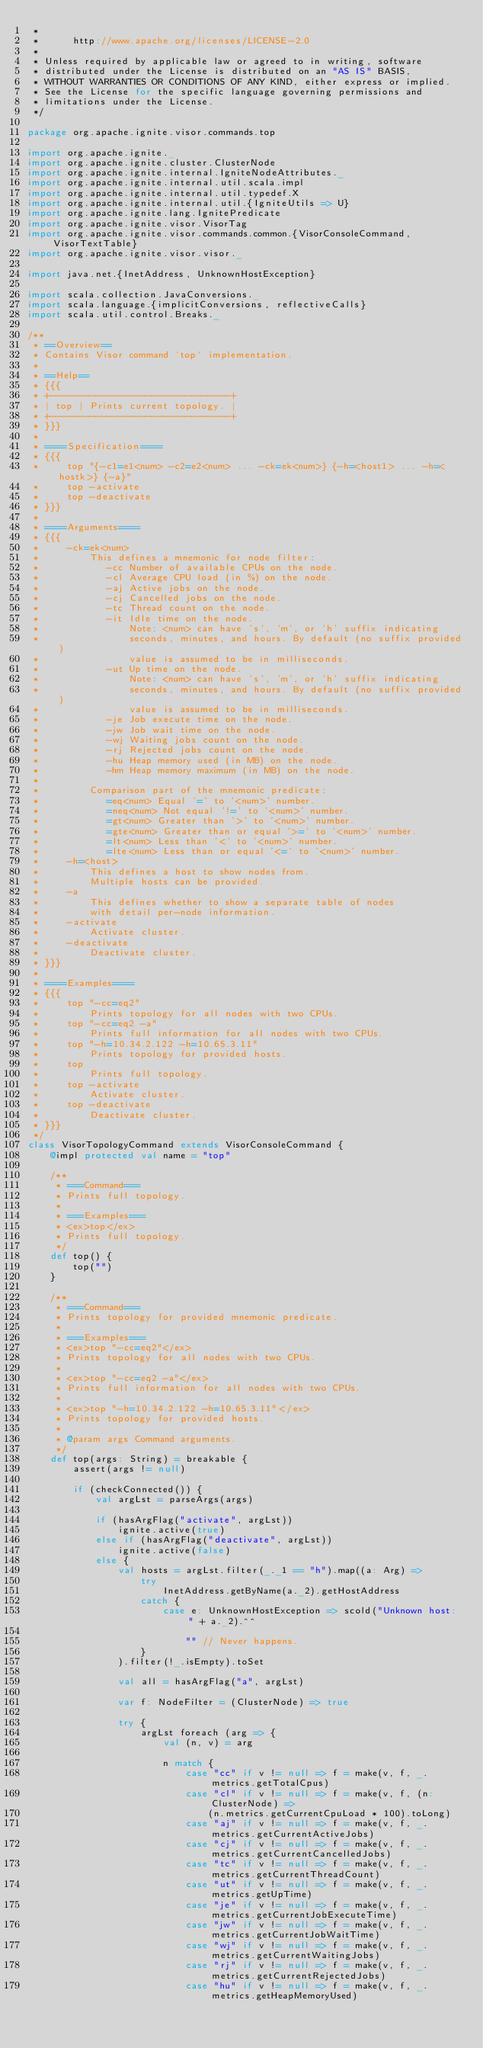Convert code to text. <code><loc_0><loc_0><loc_500><loc_500><_Scala_> *
 *      http://www.apache.org/licenses/LICENSE-2.0
 *
 * Unless required by applicable law or agreed to in writing, software
 * distributed under the License is distributed on an "AS IS" BASIS,
 * WITHOUT WARRANTIES OR CONDITIONS OF ANY KIND, either express or implied.
 * See the License for the specific language governing permissions and
 * limitations under the License.
 */

package org.apache.ignite.visor.commands.top

import org.apache.ignite._
import org.apache.ignite.cluster.ClusterNode
import org.apache.ignite.internal.IgniteNodeAttributes._
import org.apache.ignite.internal.util.scala.impl
import org.apache.ignite.internal.util.typedef.X
import org.apache.ignite.internal.util.{IgniteUtils => U}
import org.apache.ignite.lang.IgnitePredicate
import org.apache.ignite.visor.VisorTag
import org.apache.ignite.visor.commands.common.{VisorConsoleCommand, VisorTextTable}
import org.apache.ignite.visor.visor._

import java.net.{InetAddress, UnknownHostException}

import scala.collection.JavaConversions._
import scala.language.{implicitConversions, reflectiveCalls}
import scala.util.control.Breaks._

/**
 * ==Overview==
 * Contains Visor command `top` implementation.
 *
 * ==Help==
 * {{{
 * +--------------------------------+
 * | top | Prints current topology. |
 * +--------------------------------+
 * }}}
 *
 * ====Specification====
 * {{{
 *     top "{-c1=e1<num> -c2=e2<num> ... -ck=ek<num>} {-h=<host1> ... -h=<hostk>} {-a}"
 *     top -activate
 *     top -deactivate
 * }}}
 *
 * ====Arguments====
 * {{{
 *     -ck=ek<num>
 *         This defines a mnemonic for node filter:
 *            -cc Number of available CPUs on the node.
 *            -cl Average CPU load (in %) on the node.
 *            -aj Active jobs on the node.
 *            -cj Cancelled jobs on the node.
 *            -tc Thread count on the node.
 *            -it Idle time on the node.
 *                Note: <num> can have 's', 'm', or 'h' suffix indicating
 *                seconds, minutes, and hours. By default (no suffix provided)
 *                value is assumed to be in milliseconds.
 *            -ut Up time on the node.
 *                Note: <num> can have 's', 'm', or 'h' suffix indicating
 *                seconds, minutes, and hours. By default (no suffix provided)
 *                value is assumed to be in milliseconds.
 *            -je Job execute time on the node.
 *            -jw Job wait time on the node.
 *            -wj Waiting jobs count on the node.
 *            -rj Rejected jobs count on the node.
 *            -hu Heap memory used (in MB) on the node.
 *            -hm Heap memory maximum (in MB) on the node.
 *
 *         Comparison part of the mnemonic predicate:
 *            =eq<num> Equal '=' to '<num>' number.
 *            =neq<num> Not equal '!=' to '<num>' number.
 *            =gt<num> Greater than '>' to '<num>' number.
 *            =gte<num> Greater than or equal '>=' to '<num>' number.
 *            =lt<num> Less than '<' to '<num>' number.
 *            =lte<num> Less than or equal '<=' to '<num>' number.
 *     -h=<host>
 *         This defines a host to show nodes from.
 *         Multiple hosts can be provided.
 *     -a
 *         This defines whether to show a separate table of nodes
 *         with detail per-node information.
 *     -activate
 *         Activate cluster.
 *     -deactivate
 *         Deactivate cluster.
 * }}}
 *
 * ====Examples====
 * {{{
 *     top "-cc=eq2"
 *         Prints topology for all nodes with two CPUs.
 *     top "-cc=eq2 -a"
 *         Prints full information for all nodes with two CPUs.
 *     top "-h=10.34.2.122 -h=10.65.3.11"
 *         Prints topology for provided hosts.
 *     top
 *         Prints full topology.
 *     top -activate
 *         Activate cluster.
 *     top -deactivate
 *         Deactivate cluster.
 * }}}
 */
class VisorTopologyCommand extends VisorConsoleCommand {
    @impl protected val name = "top"

    /**
     * ===Command===
     * Prints full topology.
     *
     * ===Examples===
     * <ex>top</ex>
     * Prints full topology.
     */
    def top() {
        top("")
    }

    /**
     * ===Command===
     * Prints topology for provided mnemonic predicate.
     *
     * ===Examples===
     * <ex>top "-cc=eq2"</ex>
     * Prints topology for all nodes with two CPUs.
     *
     * <ex>top "-cc=eq2 -a"</ex>
     * Prints full information for all nodes with two CPUs.
     *
     * <ex>top "-h=10.34.2.122 -h=10.65.3.11"</ex>
     * Prints topology for provided hosts.
     *
     * @param args Command arguments.
     */
    def top(args: String) = breakable {
        assert(args != null)

        if (checkConnected()) {
            val argLst = parseArgs(args)

            if (hasArgFlag("activate", argLst))
                ignite.active(true)
            else if (hasArgFlag("deactivate", argLst))
                ignite.active(false)
            else {
                val hosts = argLst.filter(_._1 == "h").map((a: Arg) =>
                    try
                        InetAddress.getByName(a._2).getHostAddress
                    catch {
                        case e: UnknownHostException => scold("Unknown host: " + a._2).^^

                            "" // Never happens.
                    }
                ).filter(!_.isEmpty).toSet

                val all = hasArgFlag("a", argLst)

                var f: NodeFilter = (ClusterNode) => true

                try {
                    argLst foreach (arg => {
                        val (n, v) = arg

                        n match {
                            case "cc" if v != null => f = make(v, f, _.metrics.getTotalCpus)
                            case "cl" if v != null => f = make(v, f, (n: ClusterNode) =>
                                (n.metrics.getCurrentCpuLoad * 100).toLong)
                            case "aj" if v != null => f = make(v, f, _.metrics.getCurrentActiveJobs)
                            case "cj" if v != null => f = make(v, f, _.metrics.getCurrentCancelledJobs)
                            case "tc" if v != null => f = make(v, f, _.metrics.getCurrentThreadCount)
                            case "ut" if v != null => f = make(v, f, _.metrics.getUpTime)
                            case "je" if v != null => f = make(v, f, _.metrics.getCurrentJobExecuteTime)
                            case "jw" if v != null => f = make(v, f, _.metrics.getCurrentJobWaitTime)
                            case "wj" if v != null => f = make(v, f, _.metrics.getCurrentWaitingJobs)
                            case "rj" if v != null => f = make(v, f, _.metrics.getCurrentRejectedJobs)
                            case "hu" if v != null => f = make(v, f, _.metrics.getHeapMemoryUsed)</code> 